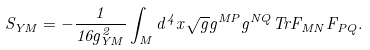Convert formula to latex. <formula><loc_0><loc_0><loc_500><loc_500>S _ { Y M } = - \frac { 1 } { 1 6 g ^ { 2 } _ { Y M } } \int _ { M } d ^ { 4 } x \sqrt { g } g ^ { M P } g ^ { N Q } T r F _ { M N } F _ { P Q } .</formula> 